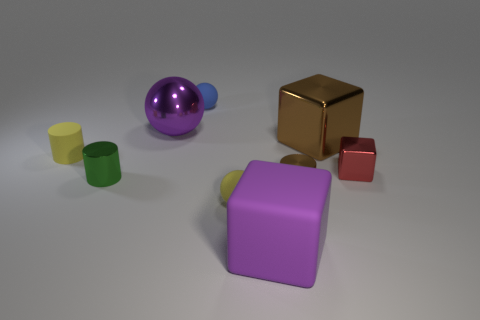Subtract all rubber spheres. How many spheres are left? 1 Add 1 small blue spheres. How many objects exist? 10 Subtract all blocks. How many objects are left? 6 Subtract 0 gray balls. How many objects are left? 9 Subtract all green rubber blocks. Subtract all small metallic cylinders. How many objects are left? 7 Add 1 large purple matte blocks. How many large purple matte blocks are left? 2 Add 9 blue metallic things. How many blue metallic things exist? 9 